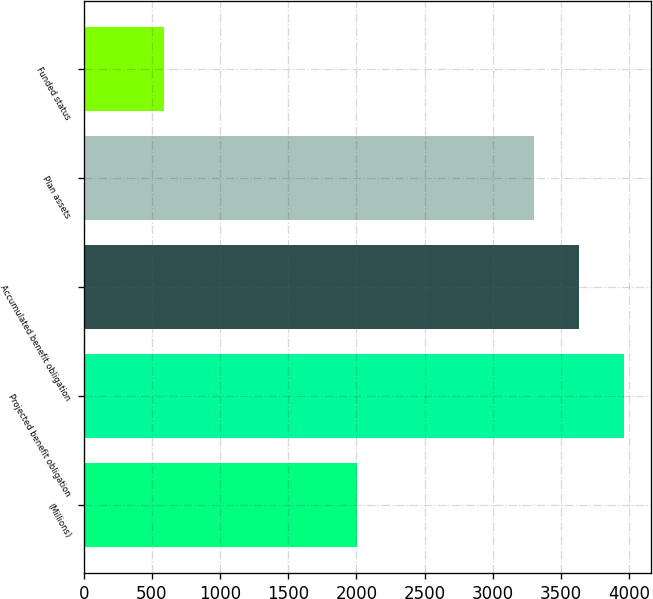Convert chart. <chart><loc_0><loc_0><loc_500><loc_500><bar_chart><fcel>(Millions)<fcel>Projected benefit obligation<fcel>Accumulated benefit obligation<fcel>Plan assets<fcel>Funded status<nl><fcel>2004<fcel>3966<fcel>3635.5<fcel>3305<fcel>591<nl></chart> 